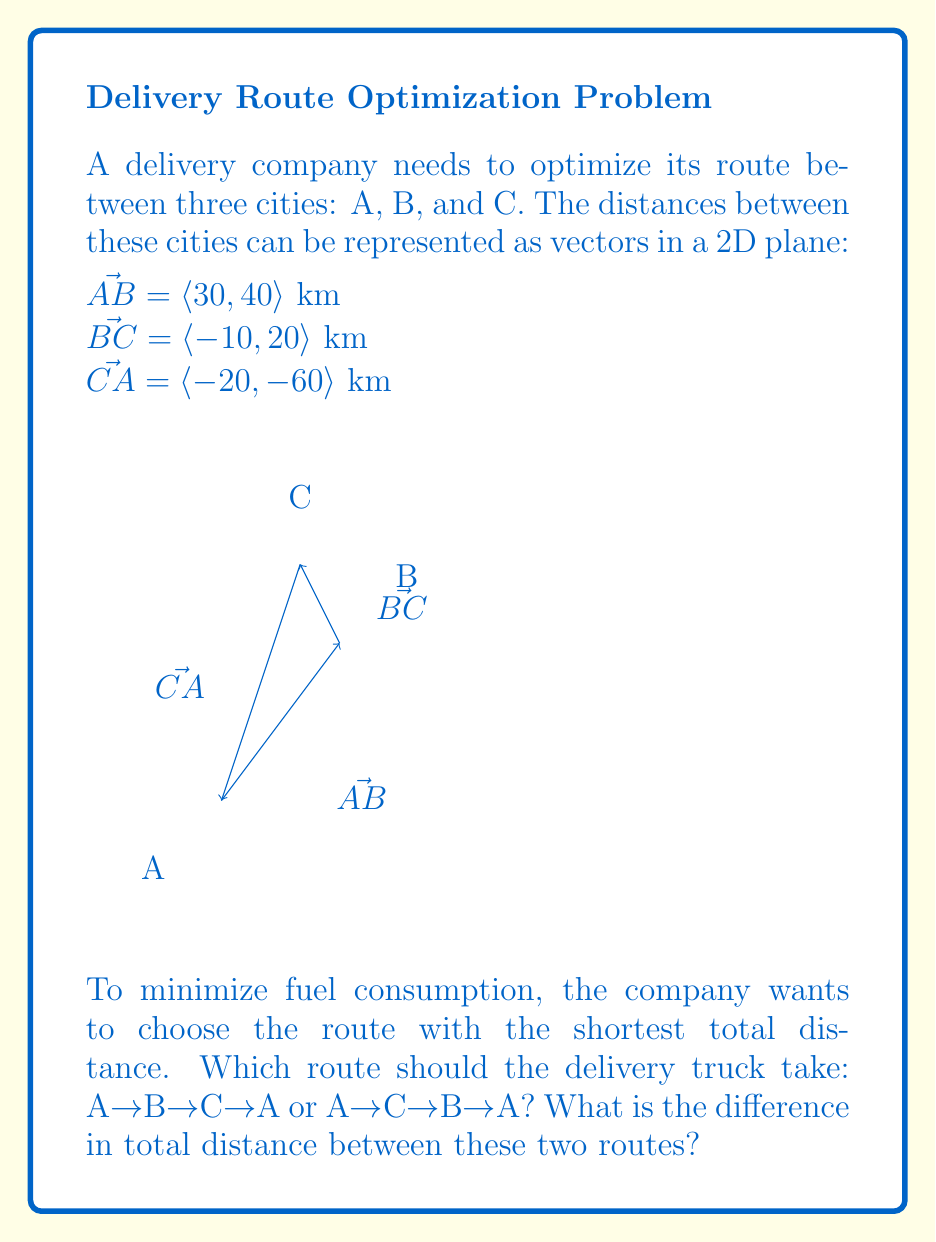Provide a solution to this math problem. Let's approach this step-by-step:

1) First, let's calculate the total distance for each route:

   Route 1: A→B→C→A
   Route 2: A→C→B→A

2) For Route 1 (A→B→C→A), we need to sum the magnitudes of $\vec{AB}$, $\vec{BC}$, and $\vec{CA}$:

   $|\vec{AB}| = \sqrt{30^2 + 40^2} = \sqrt{900 + 1600} = \sqrt{2500} = 50$ km
   $|\vec{BC}| = \sqrt{(-10)^2 + 20^2} = \sqrt{100 + 400} = \sqrt{500} \approx 22.36$ km
   $|\vec{CA}| = \sqrt{(-20)^2 + (-60)^2} = \sqrt{400 + 3600} = \sqrt{4000} \approx 63.25$ km

   Total distance for Route 1 = $50 + 22.36 + 63.25 = 135.61$ km

3) For Route 2 (A→C→B→A), we use the same vectors but in a different order:

   $|\vec{CA}| \approx 63.25$ km (already calculated)
   $|\vec{BC}| \approx 22.36$ km (already calculated)
   $|\vec{AB}| = 50$ km (already calculated)

   Total distance for Route 2 = $63.25 + 22.36 + 50 = 135.61$ km

4) The difference in total distance:
   $|Route 1 - Route 2| = |135.61 - 135.61| = 0$ km

5) Both routes have the same total distance due to the commutative property of vector addition. In a closed loop, the order of vectors doesn't affect the total distance.
Answer: Both routes are optimal; difference is 0 km. 